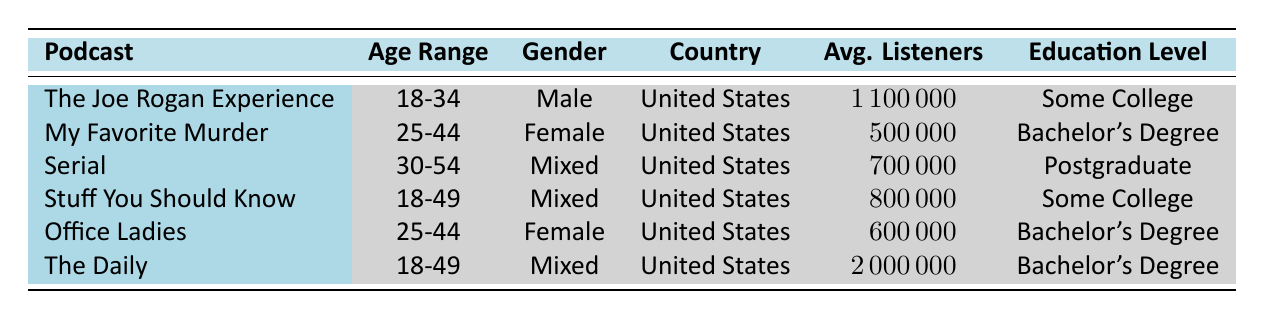What's the average number of listeners for "My Favorite Murder"? Referring to the table, "My Favorite Murder" has an average of 500,000 listeners, as this value is listed directly in the table for that podcast.
Answer: 500000 Which podcast has the highest average number of listeners? By scanning through the 'Avg. Listeners' column, "The Daily" is found to have the highest value at 2,000,000 listeners, which is greater than all other podcasts listed.
Answer: The Daily Are there any podcasts in the table that have a Mixed gender audience? The podcasts "Serial," "Stuff You Should Know," and "The Daily" are marked as having a Mixed gender audience as indicated in the 'Gender' column. Therefore, the answer to the question is yes.
Answer: Yes What is the total average number of listeners for podcasts aimed at the age range of 25-44? The relevant podcasts are "My Favorite Murder" (500,000) and "Office Ladies" (600,000). Adding these provides 500,000 + 600,000 = 1,100,000.
Answer: 1100000 How many podcasts have listeners over 1,000,000? The podcasts "The Joe Rogan Experience" with 1,100,000 and "The Daily" with 2,000,000 both exceed 1,000,000 listeners, totaling two podcasts that meet this criterion.
Answer: 2 Which country do all the podcasts listed belong to? Every podcast mentioned in the table has the country listed as the United States, which can be verified by examining the 'Country' column for each podcast.
Answer: United States What percentage of podcasts have a Bachelor's Degree education level? There are 6 podcasts total, and 3 of them ("My Favorite Murder," "Office Ladies," and "The Daily") have a Bachelor's Degree. The percentage is calculated as (3/6) * 100 = 50%.
Answer: 50% Among the podcasts aimed at the 18-49 age range, which one has the most listeners? The podcasts "The Daily" (2,000,000) and "Stuff You Should Know" (800,000) are both in this age range. Among these, "The Daily" has the highest average listeners, confirmed by comparing their 'Avg. Listeners' values.
Answer: The Daily 